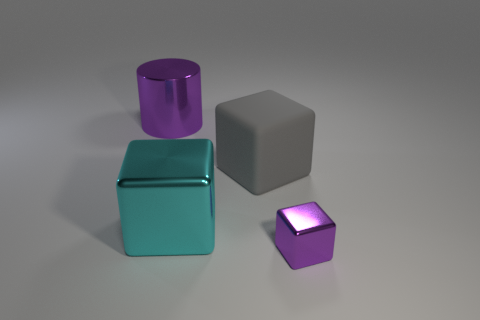Subtract all big metal blocks. How many blocks are left? 2 Subtract all cyan blocks. How many blocks are left? 2 Add 4 cubes. How many objects exist? 8 Subtract all blocks. How many objects are left? 1 Subtract all yellow cylinders. Subtract all green spheres. How many cylinders are left? 1 Subtract all big brown shiny cylinders. Subtract all purple shiny cubes. How many objects are left? 3 Add 3 purple blocks. How many purple blocks are left? 4 Add 3 tiny gray cylinders. How many tiny gray cylinders exist? 3 Subtract 0 red balls. How many objects are left? 4 